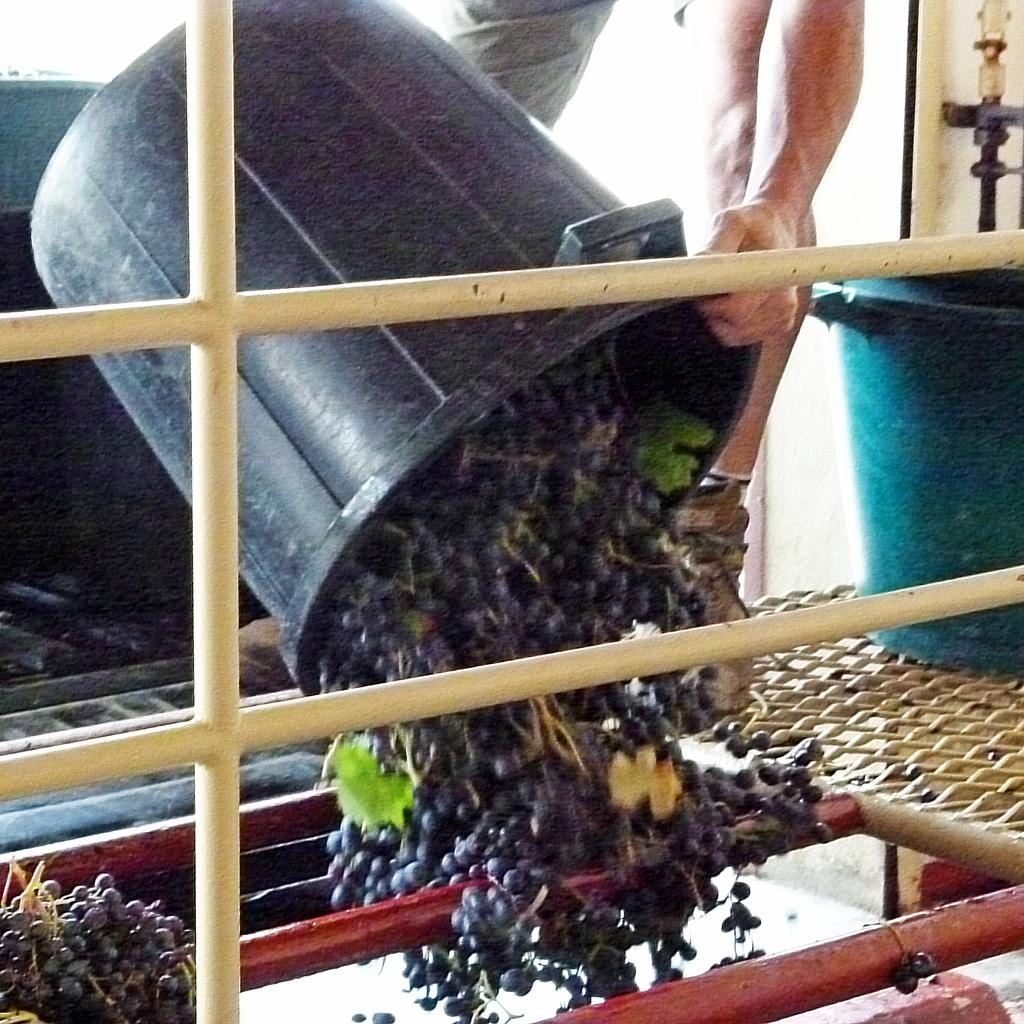What is the main subject of the image? There is a person in the image. What is the person holding in the image? The person is holding a bucket. What type of fruit can be seen in the image? There are black color grapes in the image. How does the person profit from the earthquake in the image? There is no earthquake present in the image, and therefore no such activity can be observed. 